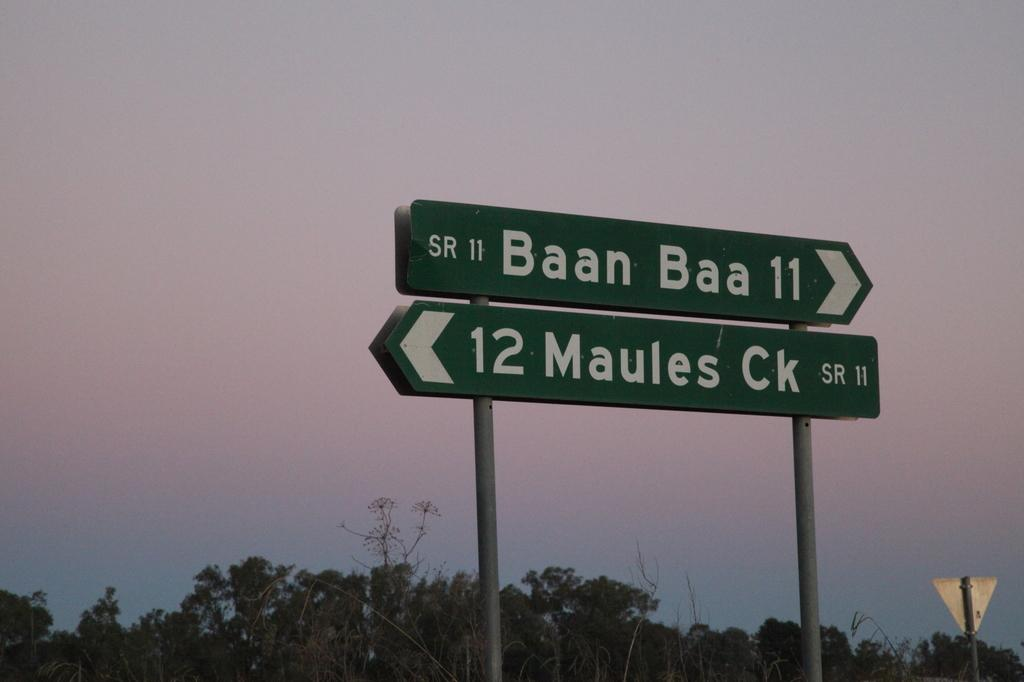<image>
Present a compact description of the photo's key features. Green signs show the directions to Baan Baa and Maules Ck. 